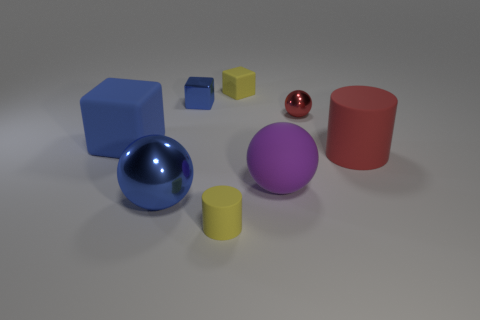Add 1 rubber blocks. How many objects exist? 9 Subtract all spheres. How many objects are left? 5 Subtract 0 brown cubes. How many objects are left? 8 Subtract all small cyan metal cubes. Subtract all big blue rubber objects. How many objects are left? 7 Add 2 purple rubber balls. How many purple rubber balls are left? 3 Add 1 blue cubes. How many blue cubes exist? 3 